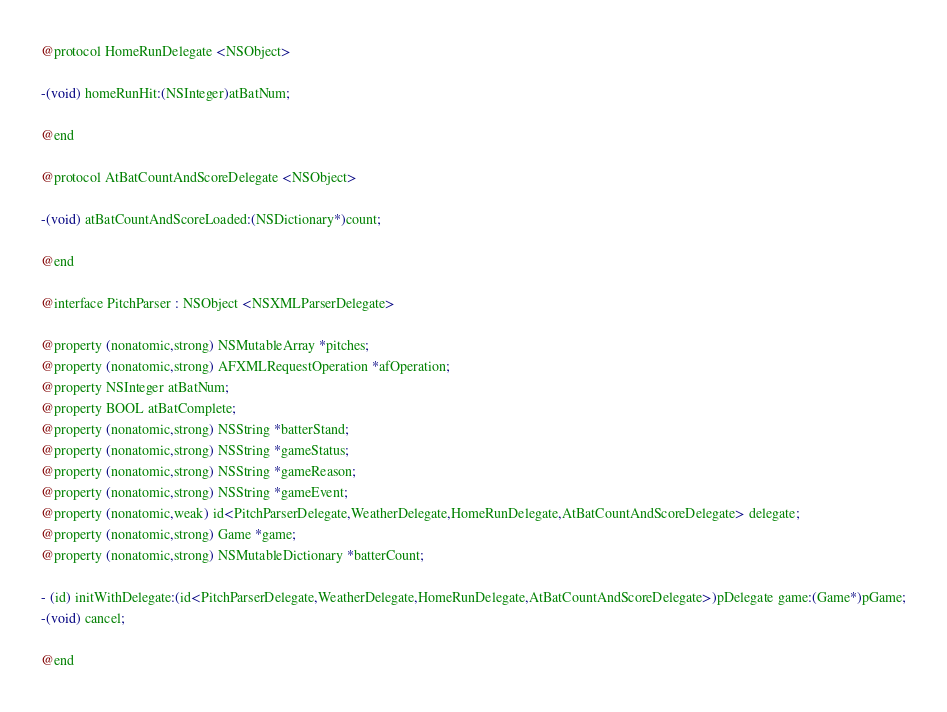Convert code to text. <code><loc_0><loc_0><loc_500><loc_500><_C_>@protocol HomeRunDelegate <NSObject>

-(void) homeRunHit:(NSInteger)atBatNum;

@end

@protocol AtBatCountAndScoreDelegate <NSObject>

-(void) atBatCountAndScoreLoaded:(NSDictionary*)count;

@end

@interface PitchParser : NSObject <NSXMLParserDelegate>

@property (nonatomic,strong) NSMutableArray *pitches;
@property (nonatomic,strong) AFXMLRequestOperation *afOperation;
@property NSInteger atBatNum;
@property BOOL atBatComplete;
@property (nonatomic,strong) NSString *batterStand;
@property (nonatomic,strong) NSString *gameStatus;
@property (nonatomic,strong) NSString *gameReason;
@property (nonatomic,strong) NSString *gameEvent;
@property (nonatomic,weak) id<PitchParserDelegate,WeatherDelegate,HomeRunDelegate,AtBatCountAndScoreDelegate> delegate;
@property (nonatomic,strong) Game *game;
@property (nonatomic,strong) NSMutableDictionary *batterCount;

- (id) initWithDelegate:(id<PitchParserDelegate,WeatherDelegate,HomeRunDelegate,AtBatCountAndScoreDelegate>)pDelegate game:(Game*)pGame;
-(void) cancel;

@end
</code> 